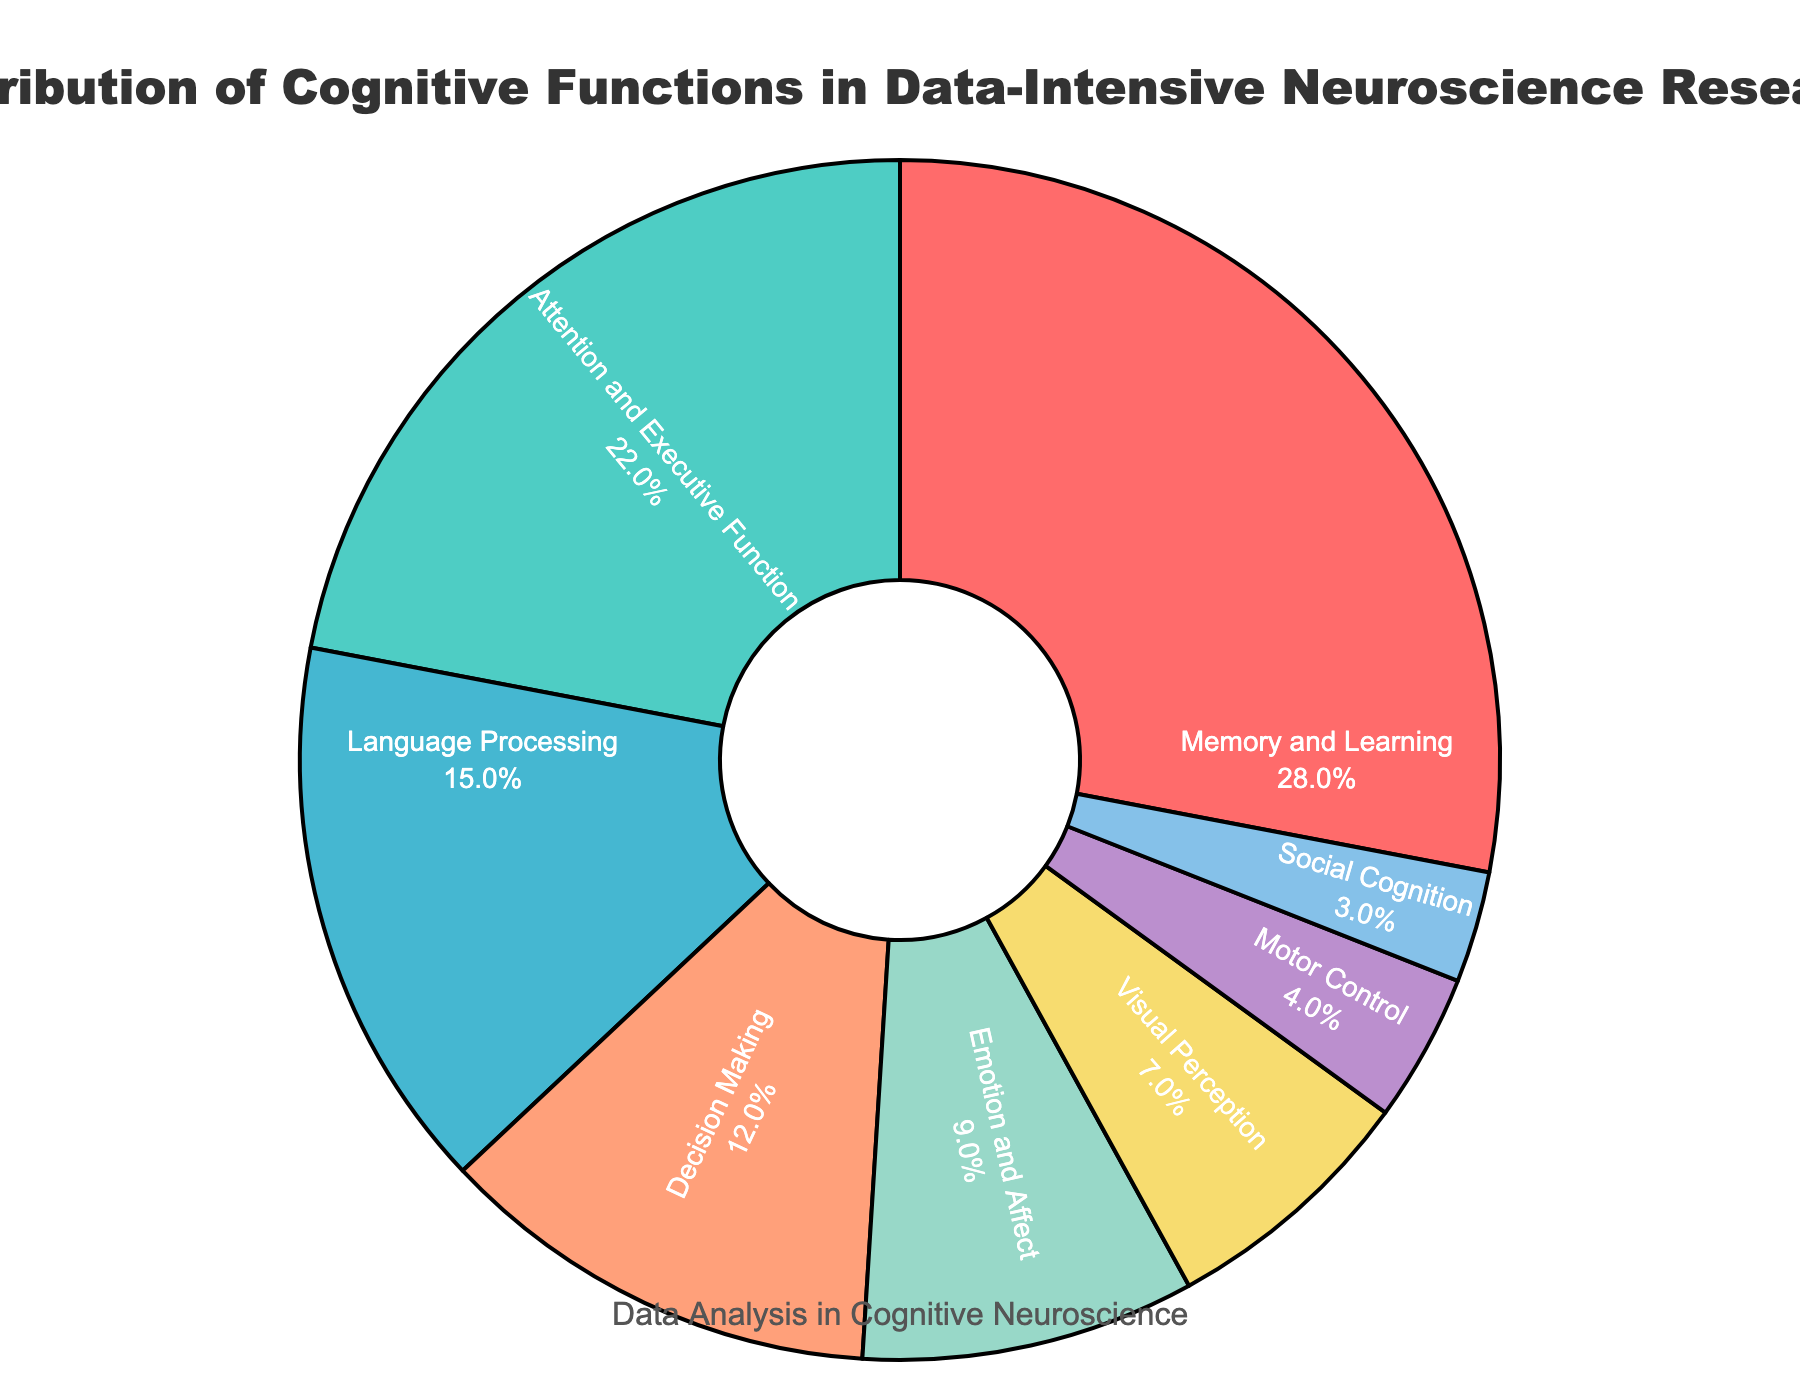What is the cognitive function with the highest percentage distribution? The cognitive function with the highest percentage distribution is labeled on the pie chart segment with the largest area. From the chart, the segment labeled "Memory and Learning" appears to be the largest.
Answer: Memory and Learning What is the combined percentage of "Attention and Executive Function" and "Language Processing"? To find the combined percentage, sum the percentages of "Attention and Executive Function" (22%) and "Language Processing" (15%). 22 + 15 = 37%.
Answer: 37% Which cognitive function has a lower percentage distribution: "Motor Control" or "Social Cognition"? Comparing the percentages of "Motor Control" (4%) and "Social Cognition" (3%) involves looking at their respective segments on the pie chart. Since 4% is greater than 3%, "Social Cognition" has a lower percentage.
Answer: Social Cognition What is the difference in percentage between "Emotion and Affect" and "Visual Perception"? To find this difference, subtract the percentage of "Visual Perception" (7%) from the percentage of "Emotion and Affect" (9%). 9 - 7 = 2%.
Answer: 2% If the total number of studies is 200, how many studies focus on "Decision Making"? To find the number of studies focusing on "Decision Making," use its percentage (12%) and multiply by the total number of studies. 12% of 200 is 0.12 * 200 = 24 studies.
Answer: 24 What is the color of the segment representing "Attention and Executive Function"? Look for the segment labeled "Attention and Executive Function" and identify its color. The color associated with this segment is a shade of turquoise or blue-green.
Answer: Turquoise Which cognitive functions have a combined percentage less than 10%? The functions that together sum to less than 10% are those with individually small percentages. "Motor Control" and "Social Cognition" have percentages of 4% and 3%, respectively, totaling 7%. Thus, they sum to less than 10%.
Answer: Motor Control and Social Cognition What percentage of the data is not accounted for by "Memory and Learning" and "Attention and Executive Function"? Subtract the combined percentage of "Memory and Learning" (28%) and "Attention and Executive Function" (22%) from 100%. This represents the remaining percentage. 100 - (28 + 22) = 50%.
Answer: 50% 